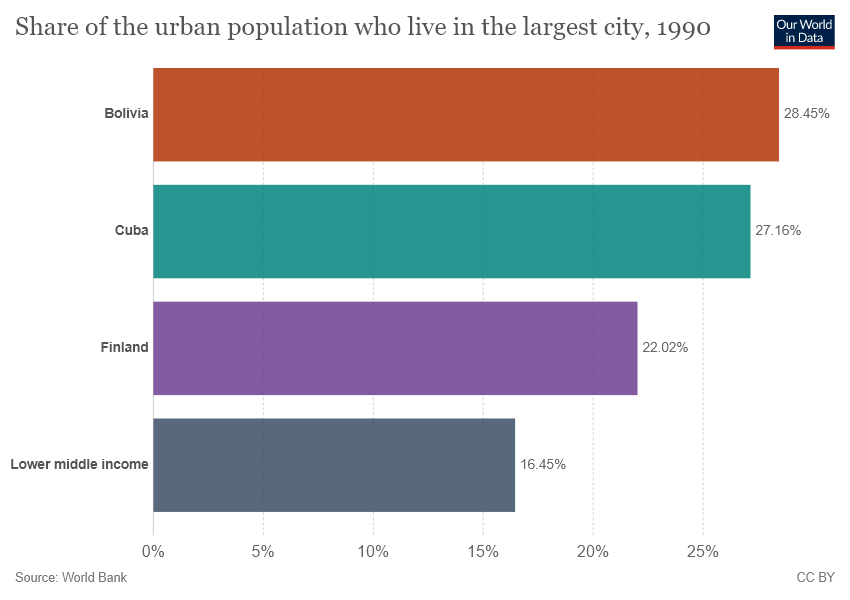Highlight a few significant elements in this photo. The data refers to Finland on February 22nd. The ratio between Finland and Cuba is approximately 0.8107511045655376... 